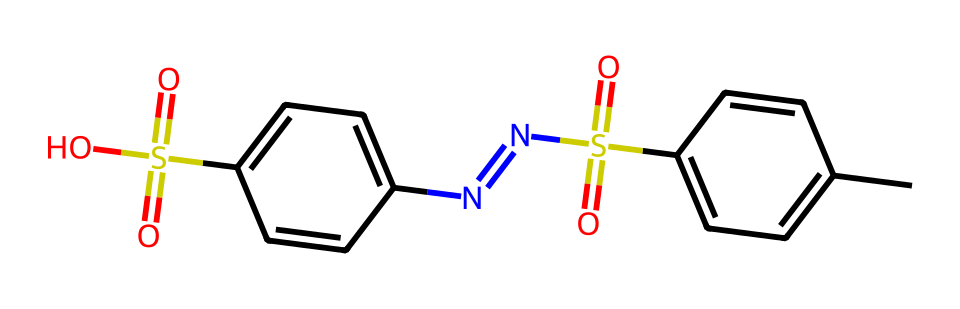What is the functional group present that indicates this compound can act as a photoresist? The presence of the sulfonamide (-S(=O)(=O)N-) and sulfonic acid (-S(=O)(=O)O) functional groups indicates that this compound can undergo chemical changes upon exposure to light, characteristic of photoresists.
Answer: sulfonamide and sulfonic acid How many nitrogen atoms are in the structure? By inspecting the given SMILES representation, we can see there are two nitrogen atoms present in the two different nitrogen-containing sections of the molecule, specifically noted by the symbols 'N='.
Answer: 2 What is the overall molecular weight of this compound? The molecular weight can be calculated by summing the atomic weights of each atom in the structure. Based on the provided SMILES, we find that the total molecular weight is approximately 326.35 g/mol after calculating the contributions from all atoms.
Answer: 326.35 How many carbon atoms are present in this chemical structure? There are a total of 14 carbon atoms counted from the carbon symbols ('C') in the SMILES representation.
Answer: 14 What type of reaction could this compound be involved in upon exposure to UV light? Upon exposure to UV light, this compound could undergo a photochemical reaction where the sulfonamide and sulfonic groups facilitate cross-linking or curing in photoresist applications, leading to patterns that can be developed further.
Answer: photochemical reaction Which part of the chemical structure is responsible for its sensitivity to light? The sulfonamide and sulfonic acid groups are primarily responsible for the compound’s photochemical sensitivity, allowing energy absorption and subsequent chemical transformations when exposed to light.
Answer: sulfonamide and sulfonic acid What role do the aromatic rings play in the chemical structure? The aromatic rings in the structure contribute to the stability and conjugation within the molecule, allowing for effective light absorption which is critical to the functionality of the photoresist in lithography processes.
Answer: stability and light absorption 